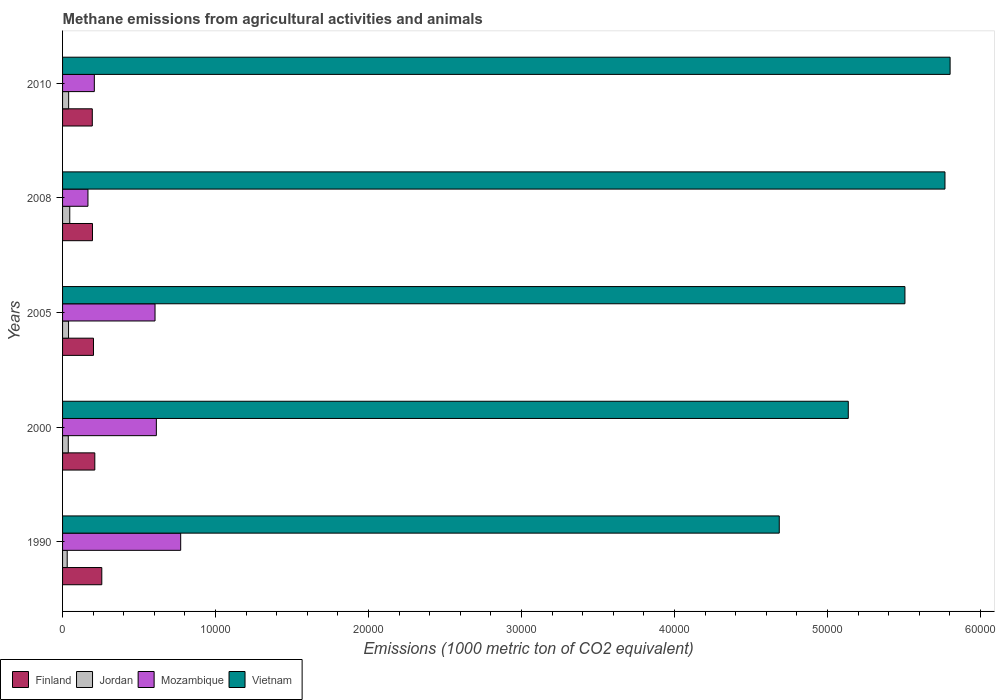How many different coloured bars are there?
Provide a succinct answer. 4. In how many cases, is the number of bars for a given year not equal to the number of legend labels?
Your response must be concise. 0. What is the amount of methane emitted in Finland in 2005?
Keep it short and to the point. 2020.8. Across all years, what is the maximum amount of methane emitted in Mozambique?
Your answer should be very brief. 7721.4. Across all years, what is the minimum amount of methane emitted in Vietnam?
Provide a short and direct response. 4.68e+04. In which year was the amount of methane emitted in Vietnam maximum?
Make the answer very short. 2010. What is the total amount of methane emitted in Jordan in the graph?
Offer a very short reply. 1937.1. What is the difference between the amount of methane emitted in Finland in 2000 and that in 2008?
Offer a terse response. 152.2. What is the difference between the amount of methane emitted in Jordan in 2010 and the amount of methane emitted in Mozambique in 2000?
Provide a short and direct response. -5733.3. What is the average amount of methane emitted in Vietnam per year?
Offer a terse response. 5.38e+04. In the year 2005, what is the difference between the amount of methane emitted in Mozambique and amount of methane emitted in Vietnam?
Your response must be concise. -4.90e+04. What is the ratio of the amount of methane emitted in Vietnam in 2005 to that in 2008?
Provide a succinct answer. 0.95. What is the difference between the highest and the second highest amount of methane emitted in Finland?
Your answer should be very brief. 456.1. What is the difference between the highest and the lowest amount of methane emitted in Mozambique?
Your answer should be very brief. 6062.1. Is the sum of the amount of methane emitted in Finland in 2000 and 2005 greater than the maximum amount of methane emitted in Jordan across all years?
Ensure brevity in your answer.  Yes. Is it the case that in every year, the sum of the amount of methane emitted in Jordan and amount of methane emitted in Finland is greater than the sum of amount of methane emitted in Mozambique and amount of methane emitted in Vietnam?
Offer a very short reply. No. What does the 1st bar from the top in 1990 represents?
Provide a succinct answer. Vietnam. What does the 4th bar from the bottom in 1990 represents?
Your response must be concise. Vietnam. How many years are there in the graph?
Give a very brief answer. 5. What is the difference between two consecutive major ticks on the X-axis?
Offer a terse response. 10000. Does the graph contain any zero values?
Your response must be concise. No. Does the graph contain grids?
Your answer should be very brief. No. Where does the legend appear in the graph?
Make the answer very short. Bottom left. How many legend labels are there?
Your answer should be compact. 4. How are the legend labels stacked?
Your answer should be very brief. Horizontal. What is the title of the graph?
Offer a terse response. Methane emissions from agricultural activities and animals. What is the label or title of the X-axis?
Make the answer very short. Emissions (1000 metric ton of CO2 equivalent). What is the Emissions (1000 metric ton of CO2 equivalent) in Finland in 1990?
Offer a very short reply. 2564. What is the Emissions (1000 metric ton of CO2 equivalent) of Jordan in 1990?
Your answer should be compact. 303.3. What is the Emissions (1000 metric ton of CO2 equivalent) in Mozambique in 1990?
Your answer should be compact. 7721.4. What is the Emissions (1000 metric ton of CO2 equivalent) of Vietnam in 1990?
Keep it short and to the point. 4.68e+04. What is the Emissions (1000 metric ton of CO2 equivalent) of Finland in 2000?
Offer a very short reply. 2107.9. What is the Emissions (1000 metric ton of CO2 equivalent) in Jordan in 2000?
Make the answer very short. 374. What is the Emissions (1000 metric ton of CO2 equivalent) in Mozambique in 2000?
Offer a very short reply. 6130.9. What is the Emissions (1000 metric ton of CO2 equivalent) in Vietnam in 2000?
Keep it short and to the point. 5.14e+04. What is the Emissions (1000 metric ton of CO2 equivalent) of Finland in 2005?
Your answer should be very brief. 2020.8. What is the Emissions (1000 metric ton of CO2 equivalent) in Jordan in 2005?
Offer a very short reply. 391.8. What is the Emissions (1000 metric ton of CO2 equivalent) of Mozambique in 2005?
Provide a short and direct response. 6043.9. What is the Emissions (1000 metric ton of CO2 equivalent) of Vietnam in 2005?
Your response must be concise. 5.51e+04. What is the Emissions (1000 metric ton of CO2 equivalent) of Finland in 2008?
Make the answer very short. 1955.7. What is the Emissions (1000 metric ton of CO2 equivalent) in Jordan in 2008?
Provide a short and direct response. 470.4. What is the Emissions (1000 metric ton of CO2 equivalent) in Mozambique in 2008?
Ensure brevity in your answer.  1659.3. What is the Emissions (1000 metric ton of CO2 equivalent) in Vietnam in 2008?
Make the answer very short. 5.77e+04. What is the Emissions (1000 metric ton of CO2 equivalent) in Finland in 2010?
Ensure brevity in your answer.  1943.6. What is the Emissions (1000 metric ton of CO2 equivalent) in Jordan in 2010?
Make the answer very short. 397.6. What is the Emissions (1000 metric ton of CO2 equivalent) of Mozambique in 2010?
Offer a terse response. 2076.1. What is the Emissions (1000 metric ton of CO2 equivalent) in Vietnam in 2010?
Keep it short and to the point. 5.80e+04. Across all years, what is the maximum Emissions (1000 metric ton of CO2 equivalent) of Finland?
Ensure brevity in your answer.  2564. Across all years, what is the maximum Emissions (1000 metric ton of CO2 equivalent) in Jordan?
Offer a very short reply. 470.4. Across all years, what is the maximum Emissions (1000 metric ton of CO2 equivalent) in Mozambique?
Make the answer very short. 7721.4. Across all years, what is the maximum Emissions (1000 metric ton of CO2 equivalent) in Vietnam?
Keep it short and to the point. 5.80e+04. Across all years, what is the minimum Emissions (1000 metric ton of CO2 equivalent) of Finland?
Your response must be concise. 1943.6. Across all years, what is the minimum Emissions (1000 metric ton of CO2 equivalent) of Jordan?
Provide a short and direct response. 303.3. Across all years, what is the minimum Emissions (1000 metric ton of CO2 equivalent) of Mozambique?
Your response must be concise. 1659.3. Across all years, what is the minimum Emissions (1000 metric ton of CO2 equivalent) of Vietnam?
Your response must be concise. 4.68e+04. What is the total Emissions (1000 metric ton of CO2 equivalent) in Finland in the graph?
Provide a short and direct response. 1.06e+04. What is the total Emissions (1000 metric ton of CO2 equivalent) of Jordan in the graph?
Your answer should be very brief. 1937.1. What is the total Emissions (1000 metric ton of CO2 equivalent) of Mozambique in the graph?
Provide a short and direct response. 2.36e+04. What is the total Emissions (1000 metric ton of CO2 equivalent) in Vietnam in the graph?
Your answer should be compact. 2.69e+05. What is the difference between the Emissions (1000 metric ton of CO2 equivalent) in Finland in 1990 and that in 2000?
Offer a terse response. 456.1. What is the difference between the Emissions (1000 metric ton of CO2 equivalent) of Jordan in 1990 and that in 2000?
Offer a very short reply. -70.7. What is the difference between the Emissions (1000 metric ton of CO2 equivalent) in Mozambique in 1990 and that in 2000?
Your answer should be very brief. 1590.5. What is the difference between the Emissions (1000 metric ton of CO2 equivalent) in Vietnam in 1990 and that in 2000?
Provide a succinct answer. -4511. What is the difference between the Emissions (1000 metric ton of CO2 equivalent) of Finland in 1990 and that in 2005?
Your response must be concise. 543.2. What is the difference between the Emissions (1000 metric ton of CO2 equivalent) of Jordan in 1990 and that in 2005?
Provide a succinct answer. -88.5. What is the difference between the Emissions (1000 metric ton of CO2 equivalent) of Mozambique in 1990 and that in 2005?
Your answer should be very brief. 1677.5. What is the difference between the Emissions (1000 metric ton of CO2 equivalent) of Vietnam in 1990 and that in 2005?
Provide a succinct answer. -8213.9. What is the difference between the Emissions (1000 metric ton of CO2 equivalent) of Finland in 1990 and that in 2008?
Your answer should be very brief. 608.3. What is the difference between the Emissions (1000 metric ton of CO2 equivalent) in Jordan in 1990 and that in 2008?
Offer a very short reply. -167.1. What is the difference between the Emissions (1000 metric ton of CO2 equivalent) of Mozambique in 1990 and that in 2008?
Make the answer very short. 6062.1. What is the difference between the Emissions (1000 metric ton of CO2 equivalent) of Vietnam in 1990 and that in 2008?
Your answer should be very brief. -1.08e+04. What is the difference between the Emissions (1000 metric ton of CO2 equivalent) in Finland in 1990 and that in 2010?
Offer a terse response. 620.4. What is the difference between the Emissions (1000 metric ton of CO2 equivalent) in Jordan in 1990 and that in 2010?
Keep it short and to the point. -94.3. What is the difference between the Emissions (1000 metric ton of CO2 equivalent) in Mozambique in 1990 and that in 2010?
Give a very brief answer. 5645.3. What is the difference between the Emissions (1000 metric ton of CO2 equivalent) in Vietnam in 1990 and that in 2010?
Give a very brief answer. -1.12e+04. What is the difference between the Emissions (1000 metric ton of CO2 equivalent) of Finland in 2000 and that in 2005?
Your answer should be very brief. 87.1. What is the difference between the Emissions (1000 metric ton of CO2 equivalent) of Jordan in 2000 and that in 2005?
Make the answer very short. -17.8. What is the difference between the Emissions (1000 metric ton of CO2 equivalent) in Mozambique in 2000 and that in 2005?
Ensure brevity in your answer.  87. What is the difference between the Emissions (1000 metric ton of CO2 equivalent) in Vietnam in 2000 and that in 2005?
Offer a very short reply. -3702.9. What is the difference between the Emissions (1000 metric ton of CO2 equivalent) in Finland in 2000 and that in 2008?
Keep it short and to the point. 152.2. What is the difference between the Emissions (1000 metric ton of CO2 equivalent) of Jordan in 2000 and that in 2008?
Your response must be concise. -96.4. What is the difference between the Emissions (1000 metric ton of CO2 equivalent) in Mozambique in 2000 and that in 2008?
Your response must be concise. 4471.6. What is the difference between the Emissions (1000 metric ton of CO2 equivalent) in Vietnam in 2000 and that in 2008?
Keep it short and to the point. -6319.4. What is the difference between the Emissions (1000 metric ton of CO2 equivalent) in Finland in 2000 and that in 2010?
Give a very brief answer. 164.3. What is the difference between the Emissions (1000 metric ton of CO2 equivalent) of Jordan in 2000 and that in 2010?
Ensure brevity in your answer.  -23.6. What is the difference between the Emissions (1000 metric ton of CO2 equivalent) in Mozambique in 2000 and that in 2010?
Your response must be concise. 4054.8. What is the difference between the Emissions (1000 metric ton of CO2 equivalent) in Vietnam in 2000 and that in 2010?
Provide a short and direct response. -6656.2. What is the difference between the Emissions (1000 metric ton of CO2 equivalent) of Finland in 2005 and that in 2008?
Ensure brevity in your answer.  65.1. What is the difference between the Emissions (1000 metric ton of CO2 equivalent) of Jordan in 2005 and that in 2008?
Offer a very short reply. -78.6. What is the difference between the Emissions (1000 metric ton of CO2 equivalent) in Mozambique in 2005 and that in 2008?
Your answer should be very brief. 4384.6. What is the difference between the Emissions (1000 metric ton of CO2 equivalent) of Vietnam in 2005 and that in 2008?
Provide a succinct answer. -2616.5. What is the difference between the Emissions (1000 metric ton of CO2 equivalent) in Finland in 2005 and that in 2010?
Keep it short and to the point. 77.2. What is the difference between the Emissions (1000 metric ton of CO2 equivalent) of Jordan in 2005 and that in 2010?
Ensure brevity in your answer.  -5.8. What is the difference between the Emissions (1000 metric ton of CO2 equivalent) of Mozambique in 2005 and that in 2010?
Offer a very short reply. 3967.8. What is the difference between the Emissions (1000 metric ton of CO2 equivalent) in Vietnam in 2005 and that in 2010?
Offer a very short reply. -2953.3. What is the difference between the Emissions (1000 metric ton of CO2 equivalent) in Finland in 2008 and that in 2010?
Provide a short and direct response. 12.1. What is the difference between the Emissions (1000 metric ton of CO2 equivalent) of Jordan in 2008 and that in 2010?
Keep it short and to the point. 72.8. What is the difference between the Emissions (1000 metric ton of CO2 equivalent) of Mozambique in 2008 and that in 2010?
Your answer should be very brief. -416.8. What is the difference between the Emissions (1000 metric ton of CO2 equivalent) in Vietnam in 2008 and that in 2010?
Give a very brief answer. -336.8. What is the difference between the Emissions (1000 metric ton of CO2 equivalent) in Finland in 1990 and the Emissions (1000 metric ton of CO2 equivalent) in Jordan in 2000?
Your answer should be very brief. 2190. What is the difference between the Emissions (1000 metric ton of CO2 equivalent) in Finland in 1990 and the Emissions (1000 metric ton of CO2 equivalent) in Mozambique in 2000?
Make the answer very short. -3566.9. What is the difference between the Emissions (1000 metric ton of CO2 equivalent) of Finland in 1990 and the Emissions (1000 metric ton of CO2 equivalent) of Vietnam in 2000?
Your answer should be very brief. -4.88e+04. What is the difference between the Emissions (1000 metric ton of CO2 equivalent) in Jordan in 1990 and the Emissions (1000 metric ton of CO2 equivalent) in Mozambique in 2000?
Give a very brief answer. -5827.6. What is the difference between the Emissions (1000 metric ton of CO2 equivalent) of Jordan in 1990 and the Emissions (1000 metric ton of CO2 equivalent) of Vietnam in 2000?
Offer a very short reply. -5.11e+04. What is the difference between the Emissions (1000 metric ton of CO2 equivalent) of Mozambique in 1990 and the Emissions (1000 metric ton of CO2 equivalent) of Vietnam in 2000?
Offer a very short reply. -4.36e+04. What is the difference between the Emissions (1000 metric ton of CO2 equivalent) in Finland in 1990 and the Emissions (1000 metric ton of CO2 equivalent) in Jordan in 2005?
Provide a succinct answer. 2172.2. What is the difference between the Emissions (1000 metric ton of CO2 equivalent) in Finland in 1990 and the Emissions (1000 metric ton of CO2 equivalent) in Mozambique in 2005?
Your answer should be very brief. -3479.9. What is the difference between the Emissions (1000 metric ton of CO2 equivalent) in Finland in 1990 and the Emissions (1000 metric ton of CO2 equivalent) in Vietnam in 2005?
Provide a succinct answer. -5.25e+04. What is the difference between the Emissions (1000 metric ton of CO2 equivalent) in Jordan in 1990 and the Emissions (1000 metric ton of CO2 equivalent) in Mozambique in 2005?
Provide a succinct answer. -5740.6. What is the difference between the Emissions (1000 metric ton of CO2 equivalent) of Jordan in 1990 and the Emissions (1000 metric ton of CO2 equivalent) of Vietnam in 2005?
Your answer should be compact. -5.48e+04. What is the difference between the Emissions (1000 metric ton of CO2 equivalent) in Mozambique in 1990 and the Emissions (1000 metric ton of CO2 equivalent) in Vietnam in 2005?
Your answer should be very brief. -4.73e+04. What is the difference between the Emissions (1000 metric ton of CO2 equivalent) of Finland in 1990 and the Emissions (1000 metric ton of CO2 equivalent) of Jordan in 2008?
Your response must be concise. 2093.6. What is the difference between the Emissions (1000 metric ton of CO2 equivalent) of Finland in 1990 and the Emissions (1000 metric ton of CO2 equivalent) of Mozambique in 2008?
Provide a short and direct response. 904.7. What is the difference between the Emissions (1000 metric ton of CO2 equivalent) in Finland in 1990 and the Emissions (1000 metric ton of CO2 equivalent) in Vietnam in 2008?
Your response must be concise. -5.51e+04. What is the difference between the Emissions (1000 metric ton of CO2 equivalent) of Jordan in 1990 and the Emissions (1000 metric ton of CO2 equivalent) of Mozambique in 2008?
Provide a succinct answer. -1356. What is the difference between the Emissions (1000 metric ton of CO2 equivalent) of Jordan in 1990 and the Emissions (1000 metric ton of CO2 equivalent) of Vietnam in 2008?
Offer a terse response. -5.74e+04. What is the difference between the Emissions (1000 metric ton of CO2 equivalent) of Mozambique in 1990 and the Emissions (1000 metric ton of CO2 equivalent) of Vietnam in 2008?
Keep it short and to the point. -5.00e+04. What is the difference between the Emissions (1000 metric ton of CO2 equivalent) in Finland in 1990 and the Emissions (1000 metric ton of CO2 equivalent) in Jordan in 2010?
Your answer should be very brief. 2166.4. What is the difference between the Emissions (1000 metric ton of CO2 equivalent) in Finland in 1990 and the Emissions (1000 metric ton of CO2 equivalent) in Mozambique in 2010?
Provide a short and direct response. 487.9. What is the difference between the Emissions (1000 metric ton of CO2 equivalent) of Finland in 1990 and the Emissions (1000 metric ton of CO2 equivalent) of Vietnam in 2010?
Your response must be concise. -5.55e+04. What is the difference between the Emissions (1000 metric ton of CO2 equivalent) in Jordan in 1990 and the Emissions (1000 metric ton of CO2 equivalent) in Mozambique in 2010?
Provide a succinct answer. -1772.8. What is the difference between the Emissions (1000 metric ton of CO2 equivalent) of Jordan in 1990 and the Emissions (1000 metric ton of CO2 equivalent) of Vietnam in 2010?
Your answer should be compact. -5.77e+04. What is the difference between the Emissions (1000 metric ton of CO2 equivalent) of Mozambique in 1990 and the Emissions (1000 metric ton of CO2 equivalent) of Vietnam in 2010?
Provide a succinct answer. -5.03e+04. What is the difference between the Emissions (1000 metric ton of CO2 equivalent) of Finland in 2000 and the Emissions (1000 metric ton of CO2 equivalent) of Jordan in 2005?
Your answer should be compact. 1716.1. What is the difference between the Emissions (1000 metric ton of CO2 equivalent) of Finland in 2000 and the Emissions (1000 metric ton of CO2 equivalent) of Mozambique in 2005?
Keep it short and to the point. -3936. What is the difference between the Emissions (1000 metric ton of CO2 equivalent) of Finland in 2000 and the Emissions (1000 metric ton of CO2 equivalent) of Vietnam in 2005?
Your answer should be compact. -5.30e+04. What is the difference between the Emissions (1000 metric ton of CO2 equivalent) of Jordan in 2000 and the Emissions (1000 metric ton of CO2 equivalent) of Mozambique in 2005?
Ensure brevity in your answer.  -5669.9. What is the difference between the Emissions (1000 metric ton of CO2 equivalent) in Jordan in 2000 and the Emissions (1000 metric ton of CO2 equivalent) in Vietnam in 2005?
Give a very brief answer. -5.47e+04. What is the difference between the Emissions (1000 metric ton of CO2 equivalent) in Mozambique in 2000 and the Emissions (1000 metric ton of CO2 equivalent) in Vietnam in 2005?
Your answer should be compact. -4.89e+04. What is the difference between the Emissions (1000 metric ton of CO2 equivalent) of Finland in 2000 and the Emissions (1000 metric ton of CO2 equivalent) of Jordan in 2008?
Give a very brief answer. 1637.5. What is the difference between the Emissions (1000 metric ton of CO2 equivalent) in Finland in 2000 and the Emissions (1000 metric ton of CO2 equivalent) in Mozambique in 2008?
Provide a succinct answer. 448.6. What is the difference between the Emissions (1000 metric ton of CO2 equivalent) in Finland in 2000 and the Emissions (1000 metric ton of CO2 equivalent) in Vietnam in 2008?
Your answer should be compact. -5.56e+04. What is the difference between the Emissions (1000 metric ton of CO2 equivalent) of Jordan in 2000 and the Emissions (1000 metric ton of CO2 equivalent) of Mozambique in 2008?
Your response must be concise. -1285.3. What is the difference between the Emissions (1000 metric ton of CO2 equivalent) of Jordan in 2000 and the Emissions (1000 metric ton of CO2 equivalent) of Vietnam in 2008?
Make the answer very short. -5.73e+04. What is the difference between the Emissions (1000 metric ton of CO2 equivalent) of Mozambique in 2000 and the Emissions (1000 metric ton of CO2 equivalent) of Vietnam in 2008?
Provide a succinct answer. -5.15e+04. What is the difference between the Emissions (1000 metric ton of CO2 equivalent) in Finland in 2000 and the Emissions (1000 metric ton of CO2 equivalent) in Jordan in 2010?
Offer a very short reply. 1710.3. What is the difference between the Emissions (1000 metric ton of CO2 equivalent) in Finland in 2000 and the Emissions (1000 metric ton of CO2 equivalent) in Mozambique in 2010?
Provide a short and direct response. 31.8. What is the difference between the Emissions (1000 metric ton of CO2 equivalent) in Finland in 2000 and the Emissions (1000 metric ton of CO2 equivalent) in Vietnam in 2010?
Offer a very short reply. -5.59e+04. What is the difference between the Emissions (1000 metric ton of CO2 equivalent) of Jordan in 2000 and the Emissions (1000 metric ton of CO2 equivalent) of Mozambique in 2010?
Your response must be concise. -1702.1. What is the difference between the Emissions (1000 metric ton of CO2 equivalent) of Jordan in 2000 and the Emissions (1000 metric ton of CO2 equivalent) of Vietnam in 2010?
Offer a very short reply. -5.76e+04. What is the difference between the Emissions (1000 metric ton of CO2 equivalent) of Mozambique in 2000 and the Emissions (1000 metric ton of CO2 equivalent) of Vietnam in 2010?
Offer a terse response. -5.19e+04. What is the difference between the Emissions (1000 metric ton of CO2 equivalent) of Finland in 2005 and the Emissions (1000 metric ton of CO2 equivalent) of Jordan in 2008?
Your answer should be compact. 1550.4. What is the difference between the Emissions (1000 metric ton of CO2 equivalent) of Finland in 2005 and the Emissions (1000 metric ton of CO2 equivalent) of Mozambique in 2008?
Provide a succinct answer. 361.5. What is the difference between the Emissions (1000 metric ton of CO2 equivalent) of Finland in 2005 and the Emissions (1000 metric ton of CO2 equivalent) of Vietnam in 2008?
Give a very brief answer. -5.57e+04. What is the difference between the Emissions (1000 metric ton of CO2 equivalent) in Jordan in 2005 and the Emissions (1000 metric ton of CO2 equivalent) in Mozambique in 2008?
Provide a short and direct response. -1267.5. What is the difference between the Emissions (1000 metric ton of CO2 equivalent) in Jordan in 2005 and the Emissions (1000 metric ton of CO2 equivalent) in Vietnam in 2008?
Your answer should be compact. -5.73e+04. What is the difference between the Emissions (1000 metric ton of CO2 equivalent) of Mozambique in 2005 and the Emissions (1000 metric ton of CO2 equivalent) of Vietnam in 2008?
Provide a short and direct response. -5.16e+04. What is the difference between the Emissions (1000 metric ton of CO2 equivalent) of Finland in 2005 and the Emissions (1000 metric ton of CO2 equivalent) of Jordan in 2010?
Offer a terse response. 1623.2. What is the difference between the Emissions (1000 metric ton of CO2 equivalent) in Finland in 2005 and the Emissions (1000 metric ton of CO2 equivalent) in Mozambique in 2010?
Your response must be concise. -55.3. What is the difference between the Emissions (1000 metric ton of CO2 equivalent) in Finland in 2005 and the Emissions (1000 metric ton of CO2 equivalent) in Vietnam in 2010?
Provide a succinct answer. -5.60e+04. What is the difference between the Emissions (1000 metric ton of CO2 equivalent) in Jordan in 2005 and the Emissions (1000 metric ton of CO2 equivalent) in Mozambique in 2010?
Provide a short and direct response. -1684.3. What is the difference between the Emissions (1000 metric ton of CO2 equivalent) in Jordan in 2005 and the Emissions (1000 metric ton of CO2 equivalent) in Vietnam in 2010?
Provide a short and direct response. -5.76e+04. What is the difference between the Emissions (1000 metric ton of CO2 equivalent) in Mozambique in 2005 and the Emissions (1000 metric ton of CO2 equivalent) in Vietnam in 2010?
Provide a succinct answer. -5.20e+04. What is the difference between the Emissions (1000 metric ton of CO2 equivalent) of Finland in 2008 and the Emissions (1000 metric ton of CO2 equivalent) of Jordan in 2010?
Your answer should be compact. 1558.1. What is the difference between the Emissions (1000 metric ton of CO2 equivalent) of Finland in 2008 and the Emissions (1000 metric ton of CO2 equivalent) of Mozambique in 2010?
Provide a short and direct response. -120.4. What is the difference between the Emissions (1000 metric ton of CO2 equivalent) of Finland in 2008 and the Emissions (1000 metric ton of CO2 equivalent) of Vietnam in 2010?
Your answer should be very brief. -5.61e+04. What is the difference between the Emissions (1000 metric ton of CO2 equivalent) of Jordan in 2008 and the Emissions (1000 metric ton of CO2 equivalent) of Mozambique in 2010?
Keep it short and to the point. -1605.7. What is the difference between the Emissions (1000 metric ton of CO2 equivalent) in Jordan in 2008 and the Emissions (1000 metric ton of CO2 equivalent) in Vietnam in 2010?
Provide a short and direct response. -5.75e+04. What is the difference between the Emissions (1000 metric ton of CO2 equivalent) of Mozambique in 2008 and the Emissions (1000 metric ton of CO2 equivalent) of Vietnam in 2010?
Your answer should be very brief. -5.64e+04. What is the average Emissions (1000 metric ton of CO2 equivalent) of Finland per year?
Provide a succinct answer. 2118.4. What is the average Emissions (1000 metric ton of CO2 equivalent) in Jordan per year?
Provide a short and direct response. 387.42. What is the average Emissions (1000 metric ton of CO2 equivalent) in Mozambique per year?
Make the answer very short. 4726.32. What is the average Emissions (1000 metric ton of CO2 equivalent) in Vietnam per year?
Provide a short and direct response. 5.38e+04. In the year 1990, what is the difference between the Emissions (1000 metric ton of CO2 equivalent) of Finland and Emissions (1000 metric ton of CO2 equivalent) of Jordan?
Provide a short and direct response. 2260.7. In the year 1990, what is the difference between the Emissions (1000 metric ton of CO2 equivalent) in Finland and Emissions (1000 metric ton of CO2 equivalent) in Mozambique?
Offer a terse response. -5157.4. In the year 1990, what is the difference between the Emissions (1000 metric ton of CO2 equivalent) in Finland and Emissions (1000 metric ton of CO2 equivalent) in Vietnam?
Provide a short and direct response. -4.43e+04. In the year 1990, what is the difference between the Emissions (1000 metric ton of CO2 equivalent) of Jordan and Emissions (1000 metric ton of CO2 equivalent) of Mozambique?
Provide a short and direct response. -7418.1. In the year 1990, what is the difference between the Emissions (1000 metric ton of CO2 equivalent) of Jordan and Emissions (1000 metric ton of CO2 equivalent) of Vietnam?
Your response must be concise. -4.65e+04. In the year 1990, what is the difference between the Emissions (1000 metric ton of CO2 equivalent) of Mozambique and Emissions (1000 metric ton of CO2 equivalent) of Vietnam?
Your response must be concise. -3.91e+04. In the year 2000, what is the difference between the Emissions (1000 metric ton of CO2 equivalent) in Finland and Emissions (1000 metric ton of CO2 equivalent) in Jordan?
Provide a short and direct response. 1733.9. In the year 2000, what is the difference between the Emissions (1000 metric ton of CO2 equivalent) of Finland and Emissions (1000 metric ton of CO2 equivalent) of Mozambique?
Provide a short and direct response. -4023. In the year 2000, what is the difference between the Emissions (1000 metric ton of CO2 equivalent) in Finland and Emissions (1000 metric ton of CO2 equivalent) in Vietnam?
Keep it short and to the point. -4.93e+04. In the year 2000, what is the difference between the Emissions (1000 metric ton of CO2 equivalent) in Jordan and Emissions (1000 metric ton of CO2 equivalent) in Mozambique?
Give a very brief answer. -5756.9. In the year 2000, what is the difference between the Emissions (1000 metric ton of CO2 equivalent) of Jordan and Emissions (1000 metric ton of CO2 equivalent) of Vietnam?
Provide a short and direct response. -5.10e+04. In the year 2000, what is the difference between the Emissions (1000 metric ton of CO2 equivalent) of Mozambique and Emissions (1000 metric ton of CO2 equivalent) of Vietnam?
Your answer should be compact. -4.52e+04. In the year 2005, what is the difference between the Emissions (1000 metric ton of CO2 equivalent) in Finland and Emissions (1000 metric ton of CO2 equivalent) in Jordan?
Give a very brief answer. 1629. In the year 2005, what is the difference between the Emissions (1000 metric ton of CO2 equivalent) in Finland and Emissions (1000 metric ton of CO2 equivalent) in Mozambique?
Your response must be concise. -4023.1. In the year 2005, what is the difference between the Emissions (1000 metric ton of CO2 equivalent) of Finland and Emissions (1000 metric ton of CO2 equivalent) of Vietnam?
Your response must be concise. -5.30e+04. In the year 2005, what is the difference between the Emissions (1000 metric ton of CO2 equivalent) of Jordan and Emissions (1000 metric ton of CO2 equivalent) of Mozambique?
Provide a succinct answer. -5652.1. In the year 2005, what is the difference between the Emissions (1000 metric ton of CO2 equivalent) of Jordan and Emissions (1000 metric ton of CO2 equivalent) of Vietnam?
Offer a very short reply. -5.47e+04. In the year 2005, what is the difference between the Emissions (1000 metric ton of CO2 equivalent) in Mozambique and Emissions (1000 metric ton of CO2 equivalent) in Vietnam?
Offer a very short reply. -4.90e+04. In the year 2008, what is the difference between the Emissions (1000 metric ton of CO2 equivalent) in Finland and Emissions (1000 metric ton of CO2 equivalent) in Jordan?
Your answer should be very brief. 1485.3. In the year 2008, what is the difference between the Emissions (1000 metric ton of CO2 equivalent) of Finland and Emissions (1000 metric ton of CO2 equivalent) of Mozambique?
Offer a very short reply. 296.4. In the year 2008, what is the difference between the Emissions (1000 metric ton of CO2 equivalent) in Finland and Emissions (1000 metric ton of CO2 equivalent) in Vietnam?
Make the answer very short. -5.57e+04. In the year 2008, what is the difference between the Emissions (1000 metric ton of CO2 equivalent) of Jordan and Emissions (1000 metric ton of CO2 equivalent) of Mozambique?
Your answer should be very brief. -1188.9. In the year 2008, what is the difference between the Emissions (1000 metric ton of CO2 equivalent) in Jordan and Emissions (1000 metric ton of CO2 equivalent) in Vietnam?
Keep it short and to the point. -5.72e+04. In the year 2008, what is the difference between the Emissions (1000 metric ton of CO2 equivalent) of Mozambique and Emissions (1000 metric ton of CO2 equivalent) of Vietnam?
Your response must be concise. -5.60e+04. In the year 2010, what is the difference between the Emissions (1000 metric ton of CO2 equivalent) of Finland and Emissions (1000 metric ton of CO2 equivalent) of Jordan?
Offer a very short reply. 1546. In the year 2010, what is the difference between the Emissions (1000 metric ton of CO2 equivalent) of Finland and Emissions (1000 metric ton of CO2 equivalent) of Mozambique?
Give a very brief answer. -132.5. In the year 2010, what is the difference between the Emissions (1000 metric ton of CO2 equivalent) of Finland and Emissions (1000 metric ton of CO2 equivalent) of Vietnam?
Your answer should be compact. -5.61e+04. In the year 2010, what is the difference between the Emissions (1000 metric ton of CO2 equivalent) in Jordan and Emissions (1000 metric ton of CO2 equivalent) in Mozambique?
Your answer should be compact. -1678.5. In the year 2010, what is the difference between the Emissions (1000 metric ton of CO2 equivalent) in Jordan and Emissions (1000 metric ton of CO2 equivalent) in Vietnam?
Provide a succinct answer. -5.76e+04. In the year 2010, what is the difference between the Emissions (1000 metric ton of CO2 equivalent) of Mozambique and Emissions (1000 metric ton of CO2 equivalent) of Vietnam?
Keep it short and to the point. -5.59e+04. What is the ratio of the Emissions (1000 metric ton of CO2 equivalent) in Finland in 1990 to that in 2000?
Provide a short and direct response. 1.22. What is the ratio of the Emissions (1000 metric ton of CO2 equivalent) in Jordan in 1990 to that in 2000?
Provide a succinct answer. 0.81. What is the ratio of the Emissions (1000 metric ton of CO2 equivalent) in Mozambique in 1990 to that in 2000?
Ensure brevity in your answer.  1.26. What is the ratio of the Emissions (1000 metric ton of CO2 equivalent) in Vietnam in 1990 to that in 2000?
Provide a short and direct response. 0.91. What is the ratio of the Emissions (1000 metric ton of CO2 equivalent) in Finland in 1990 to that in 2005?
Make the answer very short. 1.27. What is the ratio of the Emissions (1000 metric ton of CO2 equivalent) of Jordan in 1990 to that in 2005?
Provide a succinct answer. 0.77. What is the ratio of the Emissions (1000 metric ton of CO2 equivalent) of Mozambique in 1990 to that in 2005?
Ensure brevity in your answer.  1.28. What is the ratio of the Emissions (1000 metric ton of CO2 equivalent) in Vietnam in 1990 to that in 2005?
Your answer should be compact. 0.85. What is the ratio of the Emissions (1000 metric ton of CO2 equivalent) of Finland in 1990 to that in 2008?
Offer a very short reply. 1.31. What is the ratio of the Emissions (1000 metric ton of CO2 equivalent) in Jordan in 1990 to that in 2008?
Your response must be concise. 0.64. What is the ratio of the Emissions (1000 metric ton of CO2 equivalent) of Mozambique in 1990 to that in 2008?
Your answer should be very brief. 4.65. What is the ratio of the Emissions (1000 metric ton of CO2 equivalent) in Vietnam in 1990 to that in 2008?
Offer a very short reply. 0.81. What is the ratio of the Emissions (1000 metric ton of CO2 equivalent) in Finland in 1990 to that in 2010?
Your response must be concise. 1.32. What is the ratio of the Emissions (1000 metric ton of CO2 equivalent) of Jordan in 1990 to that in 2010?
Provide a succinct answer. 0.76. What is the ratio of the Emissions (1000 metric ton of CO2 equivalent) in Mozambique in 1990 to that in 2010?
Your answer should be very brief. 3.72. What is the ratio of the Emissions (1000 metric ton of CO2 equivalent) of Vietnam in 1990 to that in 2010?
Offer a very short reply. 0.81. What is the ratio of the Emissions (1000 metric ton of CO2 equivalent) in Finland in 2000 to that in 2005?
Provide a succinct answer. 1.04. What is the ratio of the Emissions (1000 metric ton of CO2 equivalent) of Jordan in 2000 to that in 2005?
Offer a very short reply. 0.95. What is the ratio of the Emissions (1000 metric ton of CO2 equivalent) of Mozambique in 2000 to that in 2005?
Make the answer very short. 1.01. What is the ratio of the Emissions (1000 metric ton of CO2 equivalent) of Vietnam in 2000 to that in 2005?
Offer a very short reply. 0.93. What is the ratio of the Emissions (1000 metric ton of CO2 equivalent) in Finland in 2000 to that in 2008?
Give a very brief answer. 1.08. What is the ratio of the Emissions (1000 metric ton of CO2 equivalent) in Jordan in 2000 to that in 2008?
Your answer should be very brief. 0.8. What is the ratio of the Emissions (1000 metric ton of CO2 equivalent) of Mozambique in 2000 to that in 2008?
Give a very brief answer. 3.69. What is the ratio of the Emissions (1000 metric ton of CO2 equivalent) of Vietnam in 2000 to that in 2008?
Make the answer very short. 0.89. What is the ratio of the Emissions (1000 metric ton of CO2 equivalent) in Finland in 2000 to that in 2010?
Ensure brevity in your answer.  1.08. What is the ratio of the Emissions (1000 metric ton of CO2 equivalent) of Jordan in 2000 to that in 2010?
Ensure brevity in your answer.  0.94. What is the ratio of the Emissions (1000 metric ton of CO2 equivalent) in Mozambique in 2000 to that in 2010?
Your answer should be compact. 2.95. What is the ratio of the Emissions (1000 metric ton of CO2 equivalent) of Vietnam in 2000 to that in 2010?
Ensure brevity in your answer.  0.89. What is the ratio of the Emissions (1000 metric ton of CO2 equivalent) in Jordan in 2005 to that in 2008?
Your answer should be very brief. 0.83. What is the ratio of the Emissions (1000 metric ton of CO2 equivalent) of Mozambique in 2005 to that in 2008?
Your answer should be compact. 3.64. What is the ratio of the Emissions (1000 metric ton of CO2 equivalent) in Vietnam in 2005 to that in 2008?
Make the answer very short. 0.95. What is the ratio of the Emissions (1000 metric ton of CO2 equivalent) in Finland in 2005 to that in 2010?
Make the answer very short. 1.04. What is the ratio of the Emissions (1000 metric ton of CO2 equivalent) in Jordan in 2005 to that in 2010?
Your response must be concise. 0.99. What is the ratio of the Emissions (1000 metric ton of CO2 equivalent) in Mozambique in 2005 to that in 2010?
Your answer should be very brief. 2.91. What is the ratio of the Emissions (1000 metric ton of CO2 equivalent) of Vietnam in 2005 to that in 2010?
Your response must be concise. 0.95. What is the ratio of the Emissions (1000 metric ton of CO2 equivalent) in Jordan in 2008 to that in 2010?
Offer a terse response. 1.18. What is the ratio of the Emissions (1000 metric ton of CO2 equivalent) of Mozambique in 2008 to that in 2010?
Keep it short and to the point. 0.8. What is the difference between the highest and the second highest Emissions (1000 metric ton of CO2 equivalent) of Finland?
Your answer should be very brief. 456.1. What is the difference between the highest and the second highest Emissions (1000 metric ton of CO2 equivalent) of Jordan?
Keep it short and to the point. 72.8. What is the difference between the highest and the second highest Emissions (1000 metric ton of CO2 equivalent) of Mozambique?
Your response must be concise. 1590.5. What is the difference between the highest and the second highest Emissions (1000 metric ton of CO2 equivalent) in Vietnam?
Give a very brief answer. 336.8. What is the difference between the highest and the lowest Emissions (1000 metric ton of CO2 equivalent) in Finland?
Offer a terse response. 620.4. What is the difference between the highest and the lowest Emissions (1000 metric ton of CO2 equivalent) in Jordan?
Your answer should be compact. 167.1. What is the difference between the highest and the lowest Emissions (1000 metric ton of CO2 equivalent) in Mozambique?
Give a very brief answer. 6062.1. What is the difference between the highest and the lowest Emissions (1000 metric ton of CO2 equivalent) of Vietnam?
Keep it short and to the point. 1.12e+04. 